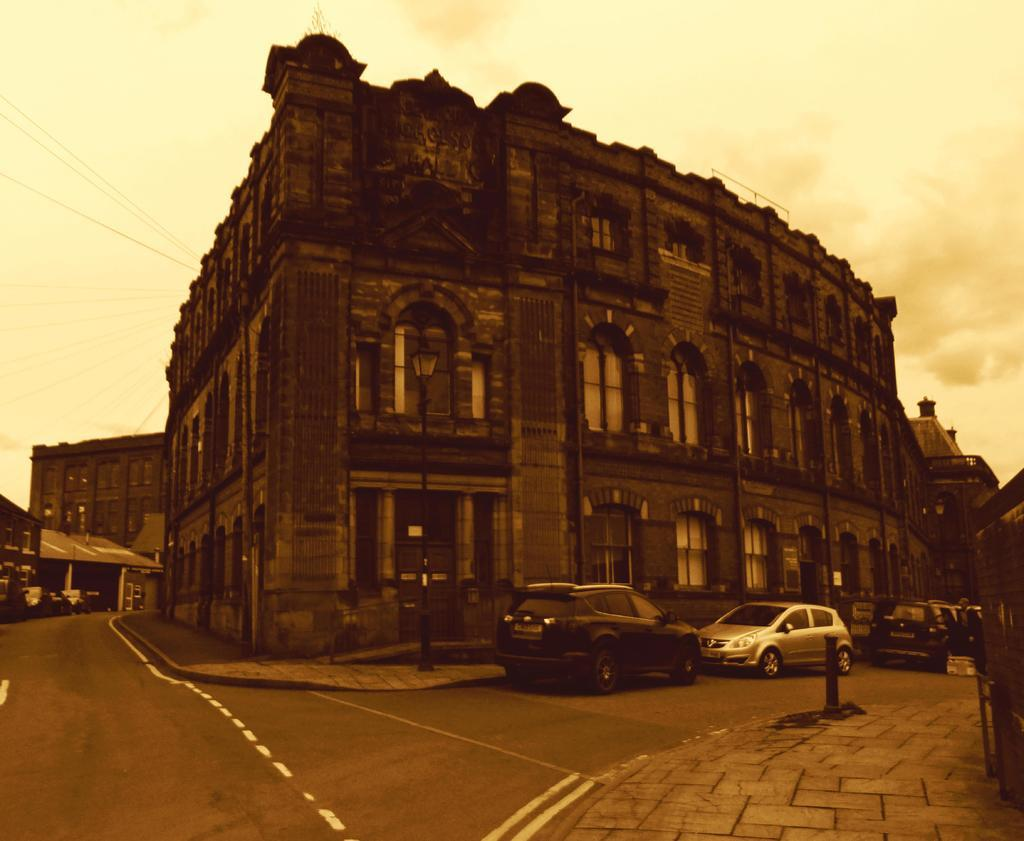What can be seen on the road in the image? There are vehicles on the road in the image. What else is visible near the road? There are buildings visible beside the road. What can be seen in the background of the image? The sky is visible in the background of the image. What type of yam is being smoked in the sock in the image? There is no yam, smoke, or sock present in the image. How many socks are visible in the image? There are no socks visible in the image. 